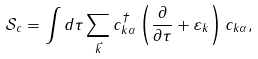Convert formula to latex. <formula><loc_0><loc_0><loc_500><loc_500>\mathcal { S } _ { c } = \int d \tau \sum _ { \vec { k } } c _ { k \alpha } ^ { \dagger } \left ( \frac { \partial } { \partial \tau } + \varepsilon _ { k } \right ) c _ { k \alpha } ,</formula> 